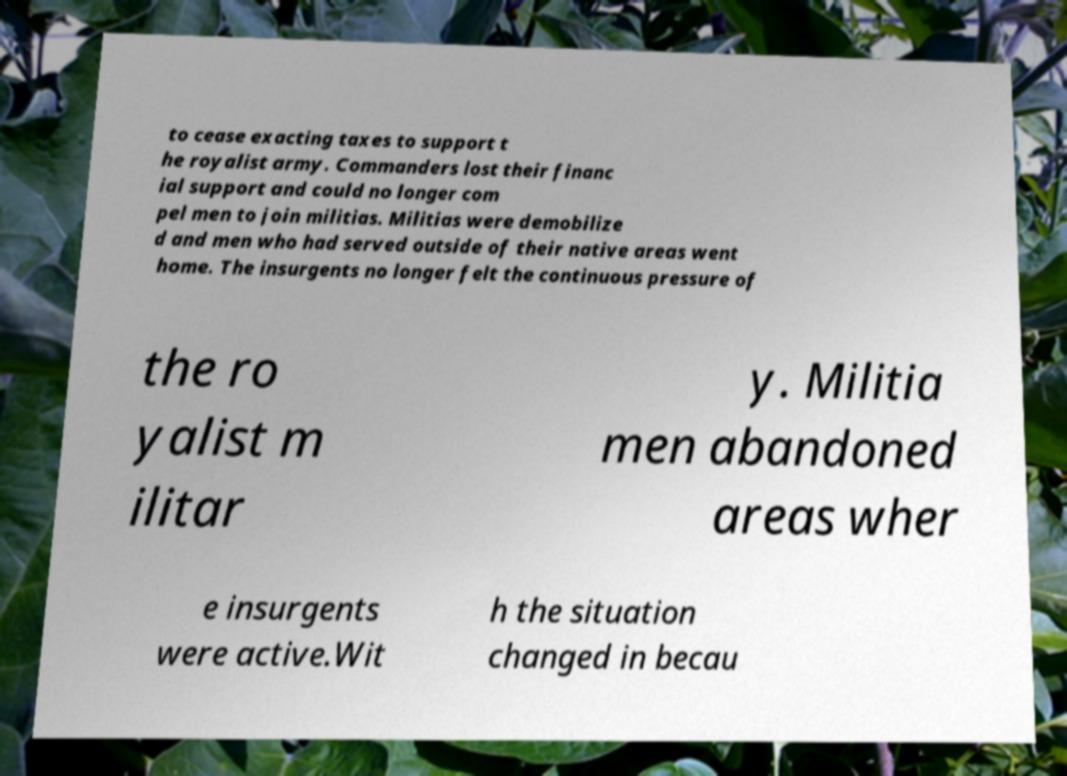I need the written content from this picture converted into text. Can you do that? to cease exacting taxes to support t he royalist army. Commanders lost their financ ial support and could no longer com pel men to join militias. Militias were demobilize d and men who had served outside of their native areas went home. The insurgents no longer felt the continuous pressure of the ro yalist m ilitar y. Militia men abandoned areas wher e insurgents were active.Wit h the situation changed in becau 